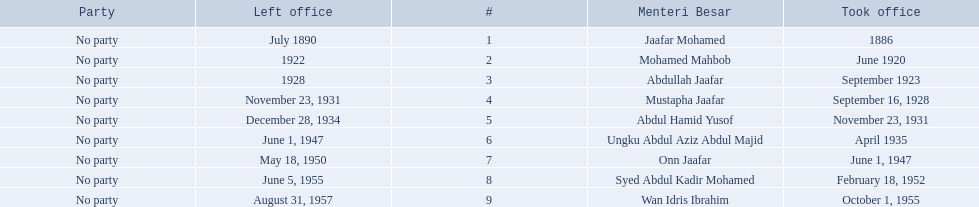Who were all of the menteri besars? Jaafar Mohamed, Mohamed Mahbob, Abdullah Jaafar, Mustapha Jaafar, Abdul Hamid Yusof, Ungku Abdul Aziz Abdul Majid, Onn Jaafar, Syed Abdul Kadir Mohamed, Wan Idris Ibrahim. When did they take office? 1886, June 1920, September 1923, September 16, 1928, November 23, 1931, April 1935, June 1, 1947, February 18, 1952, October 1, 1955. And when did they leave? July 1890, 1922, 1928, November 23, 1931, December 28, 1934, June 1, 1947, May 18, 1950, June 5, 1955, August 31, 1957. Now, who was in office for less than four years? Mohamed Mahbob. 